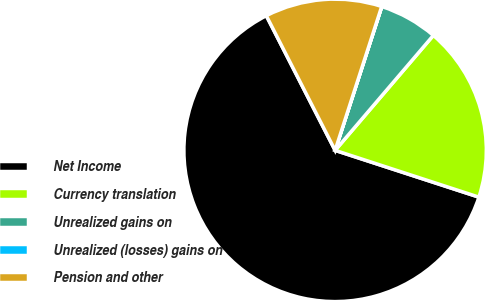Convert chart to OTSL. <chart><loc_0><loc_0><loc_500><loc_500><pie_chart><fcel>Net Income<fcel>Currency translation<fcel>Unrealized gains on<fcel>Unrealized (losses) gains on<fcel>Pension and other<nl><fcel>62.47%<fcel>18.75%<fcel>6.26%<fcel>0.01%<fcel>12.5%<nl></chart> 